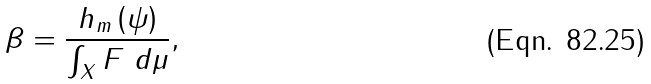Convert formula to latex. <formula><loc_0><loc_0><loc_500><loc_500>\beta = \frac { h _ { m } \left ( \psi \right ) } { \int _ { X } F \ d \mu } ,</formula> 